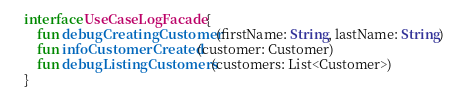<code> <loc_0><loc_0><loc_500><loc_500><_Kotlin_>
interface UseCaseLogFacade {
    fun debugCreatingCustomer(firstName: String, lastName: String)
    fun infoCustomerCreated(customer: Customer)
    fun debugListingCustomers(customers: List<Customer>)
}
</code> 